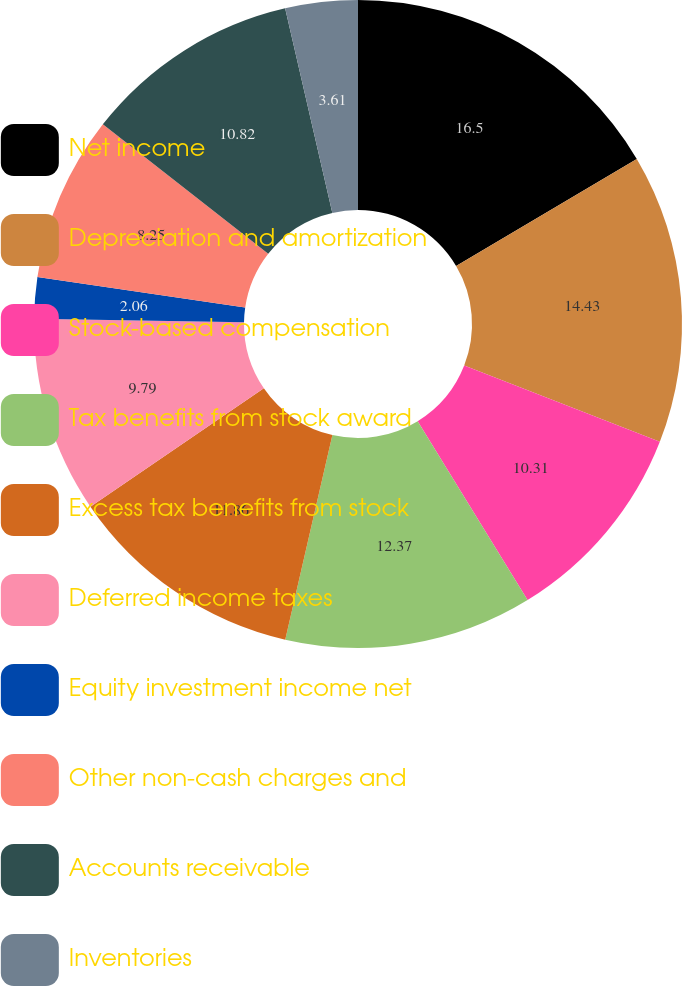Convert chart to OTSL. <chart><loc_0><loc_0><loc_500><loc_500><pie_chart><fcel>Net income<fcel>Depreciation and amortization<fcel>Stock-based compensation<fcel>Tax benefits from stock award<fcel>Excess tax benefits from stock<fcel>Deferred income taxes<fcel>Equity investment income net<fcel>Other non-cash charges and<fcel>Accounts receivable<fcel>Inventories<nl><fcel>16.49%<fcel>14.43%<fcel>10.31%<fcel>12.37%<fcel>11.86%<fcel>9.79%<fcel>2.06%<fcel>8.25%<fcel>10.82%<fcel>3.61%<nl></chart> 